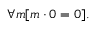Convert formula to latex. <formula><loc_0><loc_0><loc_500><loc_500>\forall m [ m \cdot 0 = 0 ] .</formula> 